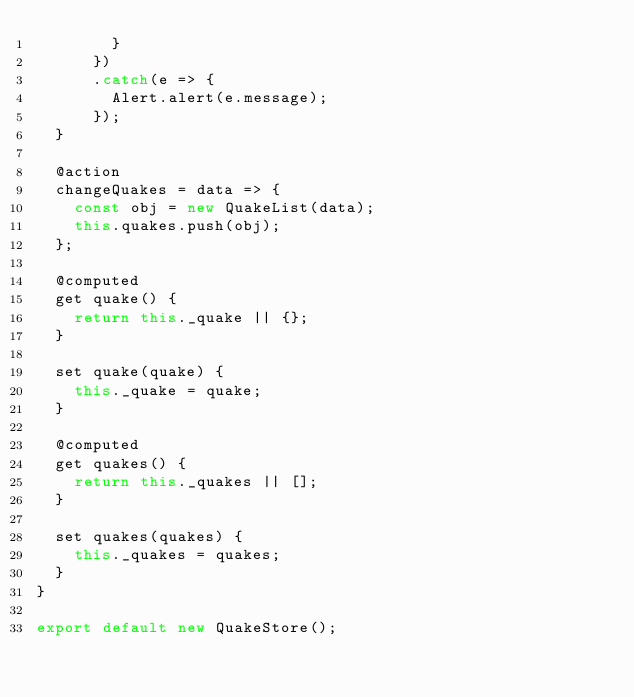Convert code to text. <code><loc_0><loc_0><loc_500><loc_500><_JavaScript_>        }
      })
      .catch(e => {
        Alert.alert(e.message);
      });
  }

  @action
  changeQuakes = data => {
    const obj = new QuakeList(data);
    this.quakes.push(obj);
  };

  @computed
  get quake() {
    return this._quake || {};
  }

  set quake(quake) {
    this._quake = quake;
  }

  @computed
  get quakes() {
    return this._quakes || [];
  }

  set quakes(quakes) {
    this._quakes = quakes;
  }
}

export default new QuakeStore();
</code> 